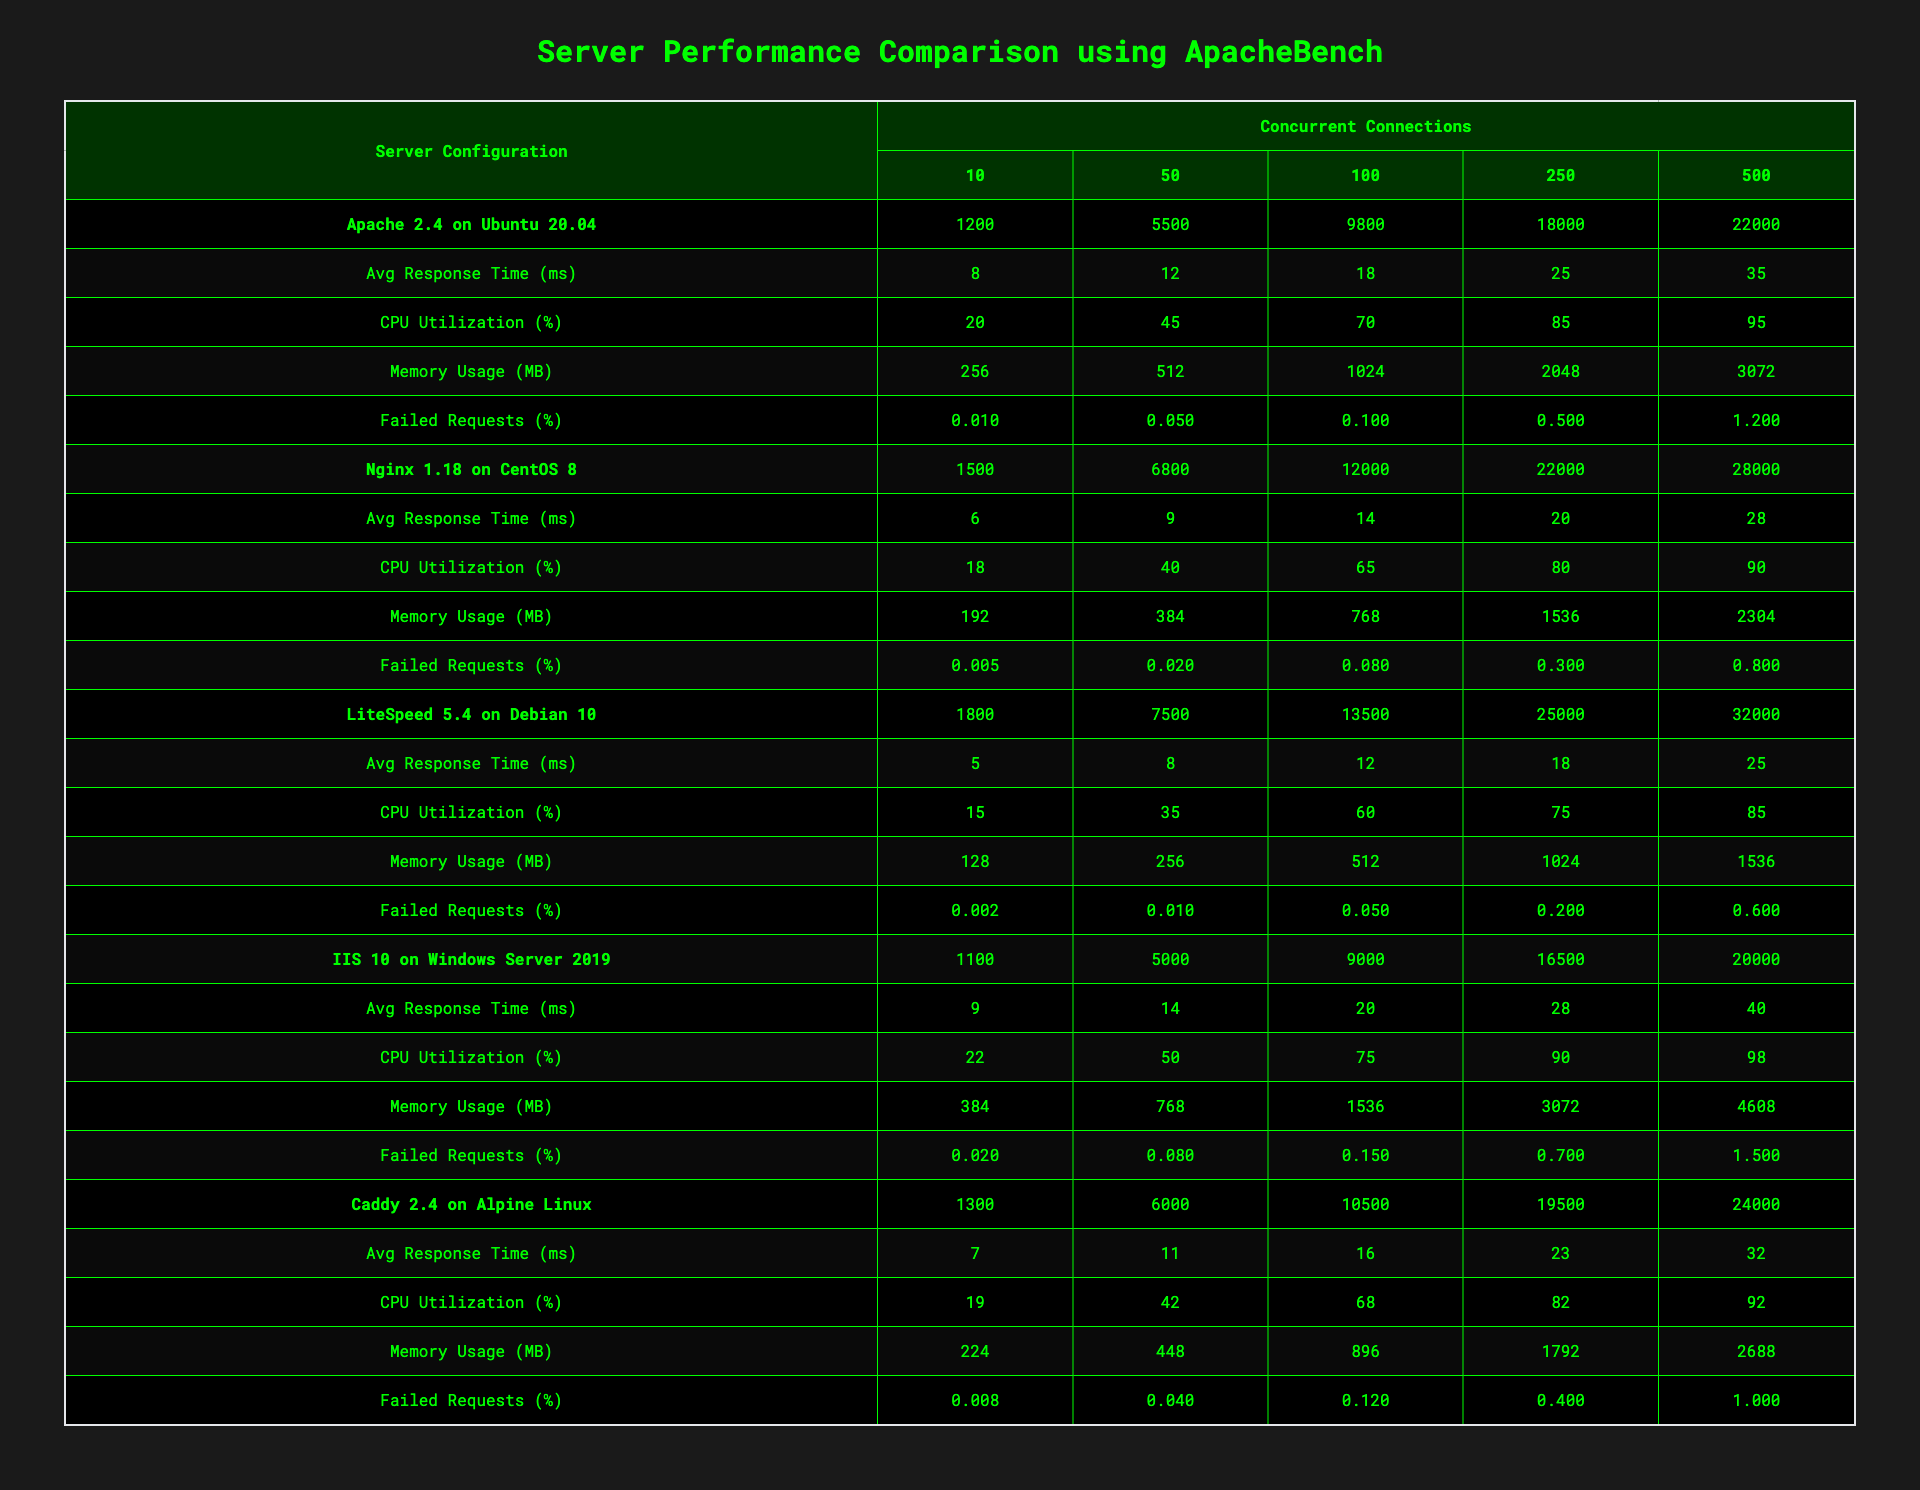What is the requests per second for LiteSpeed at 250 concurrent connections? In the table, LiteSpeed's corresponding requests per second value at 250 concurrent connections is 25000.
Answer: 25000 What is the average response time in milliseconds for Nginx at 100 concurrent connections? The average response time for Nginx at 100 concurrent connections is specified in the table as 14 ms.
Answer: 14 ms Which server configuration has the highest CPU utilization at 500 concurrent connections? By comparing the CPU utilization percentages at 500 concurrent connections, LiteSpeed has the highest value of 85%.
Answer: LiteSpeed What is the total memory usage for Apache at all connection levels? Sum the memory values for Apache across all connection levels: 256 + 512 + 1024 + 2048 + 3072 = 5120 MB.
Answer: 5120 MB Is the percentage of failed requests for Caddy at 10 concurrent connections higher than that for IIS? The failed requests percentage for Caddy at 10 concurrent connections is 0.008%, while for IIS it is 0.02%. Since 0.008% is less than 0.02%, the statement is false.
Answer: No What server configuration shows the best balance of low average response time and high requests per second at 100 concurrent connections? At 100 concurrent connections, LiteSpeed has 13500 requests per second and an average response time of 12 ms, which is the best balance compared to other configurations.
Answer: LiteSpeed What is the median memory usage for all server configurations at 250 concurrent connections? The memory usage values at 250 concurrent connections are 2048 (Apache), 1536 (Nginx), 1024 (LiteSpeed), 3072 (IIS), and 1792 (Caddy). Sorting these gives 1024, 1536, 1792, 2048, 3072; the median (middle value) is 1792 MB.
Answer: 1792 MB Which server has the lowest percentage of failed requests at 500 concurrent connections? Looking at the table, LiteSpeed has the lowest failed requests percentage at 1.2% at 500 concurrent connections.
Answer: LiteSpeed What is the difference in requests per second between Nginx and IIS at 10 concurrent connections? Nginx has 1500 requests per second and IIS has 1100 requests per second at 10 concurrent connections. The difference is 1500 - 1100 = 400 requests per second.
Answer: 400 requests per second At 250 concurrent connections, how much more is the average response time for IIS compared to Apache? At 250 connections, the average response time for IIS is 28 ms and for Apache is 25 ms. The difference is 28 - 25 = 3 ms.
Answer: 3 ms Which configuration has a CPU utilization of over 90% at 500 concurrent connections? The table shows that IIS has a CPU utilization of 98% at 500 concurrent connections, which is over 90%.
Answer: IIS 